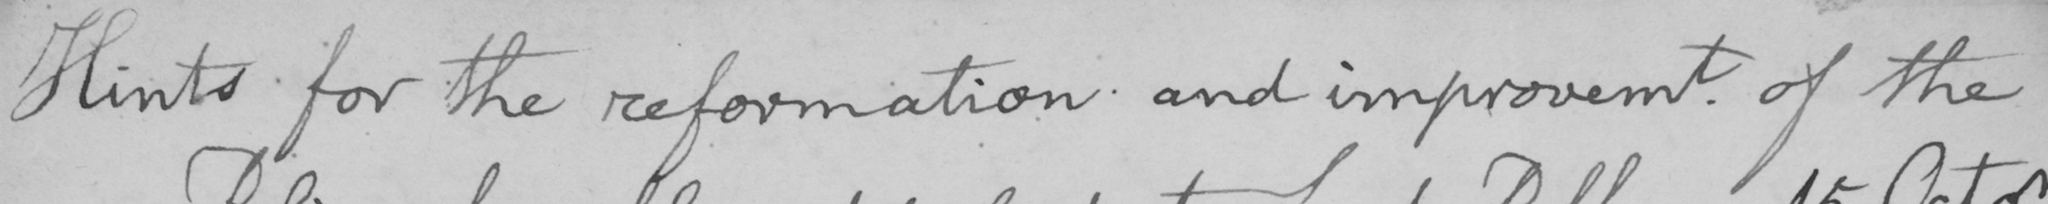What is written in this line of handwriting? Hints for the reformation and improvement of the 